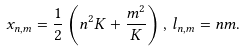Convert formula to latex. <formula><loc_0><loc_0><loc_500><loc_500>x _ { n , m } = \frac { 1 } { 2 } \left ( n ^ { 2 } K + \frac { m ^ { 2 } } { K } \right ) , \, l _ { n , m } = n m .</formula> 